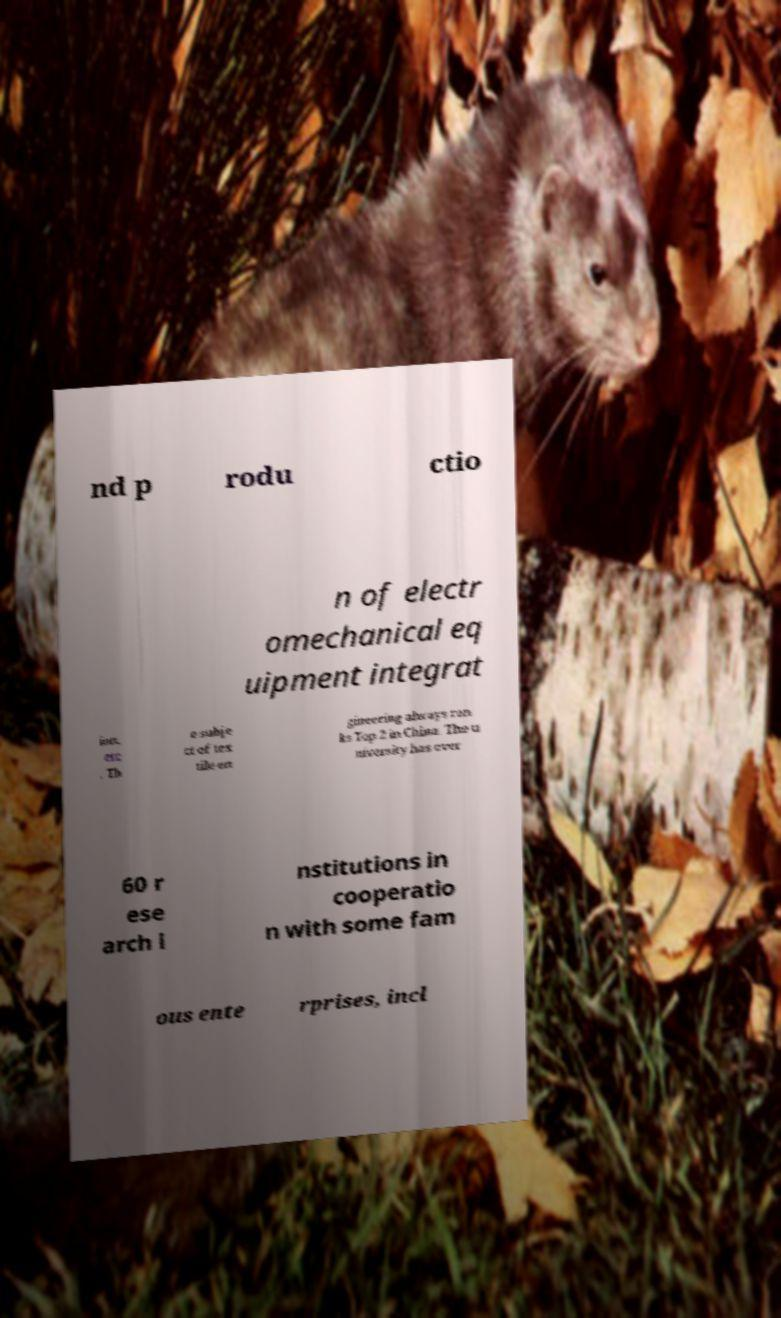Can you accurately transcribe the text from the provided image for me? nd p rodu ctio n of electr omechanical eq uipment integrat ion, etc . Th e subje ct of tex tile en gineering always ran ks Top 2 in China. The u niversity has over 60 r ese arch i nstitutions in cooperatio n with some fam ous ente rprises, incl 